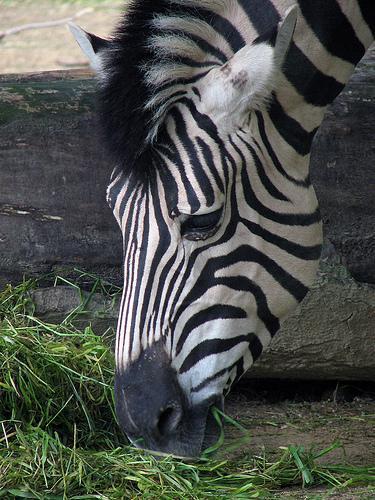How many zebras are there?
Give a very brief answer. 1. 